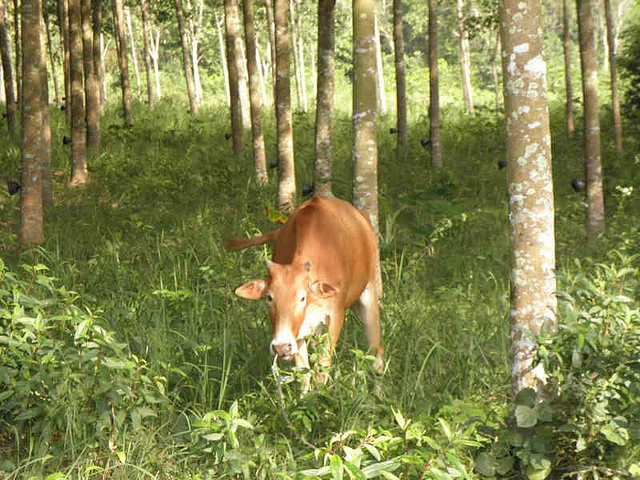Describe the objects in this image and their specific colors. I can see a cow in khaki, tan, red, and ivory tones in this image. 